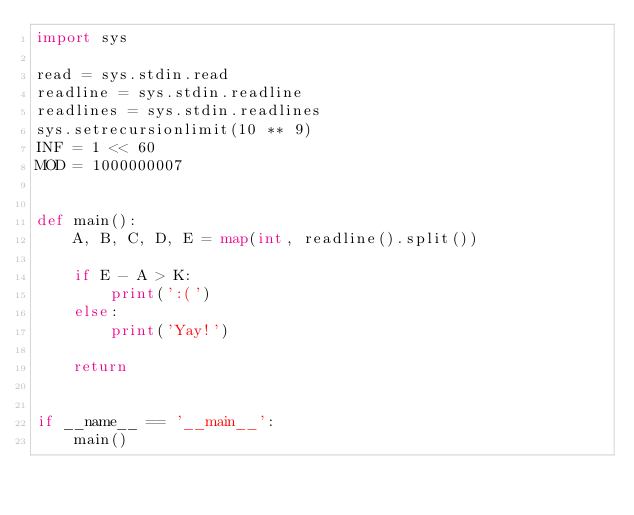Convert code to text. <code><loc_0><loc_0><loc_500><loc_500><_Python_>import sys

read = sys.stdin.read
readline = sys.stdin.readline
readlines = sys.stdin.readlines
sys.setrecursionlimit(10 ** 9)
INF = 1 << 60
MOD = 1000000007


def main():
    A, B, C, D, E = map(int, readline().split())

    if E - A > K:
        print(':(')
    else:
        print('Yay!')

    return


if __name__ == '__main__':
    main()
</code> 